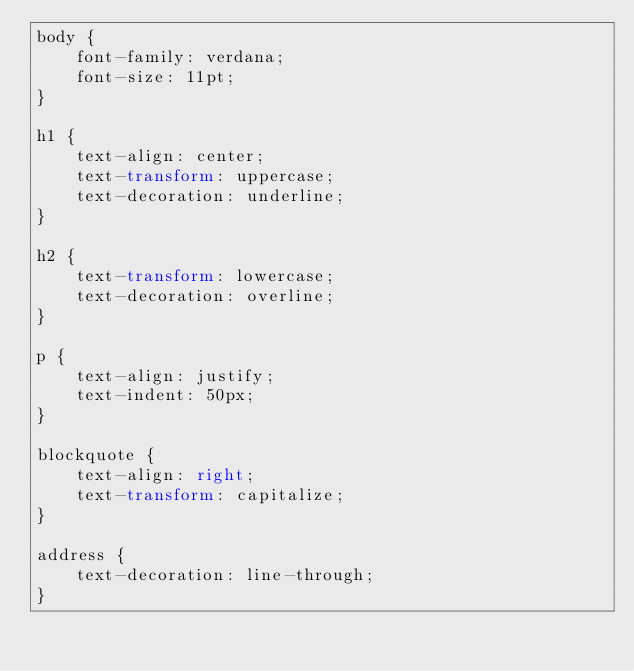<code> <loc_0><loc_0><loc_500><loc_500><_CSS_>body {
    font-family: verdana;
    font-size: 11pt;
}

h1 {
    text-align: center;
    text-transform: uppercase;
    text-decoration: underline;
}

h2 {
    text-transform: lowercase;
    text-decoration: overline;
}

p {
    text-align: justify;
    text-indent: 50px;
}

blockquote {
    text-align: right;
    text-transform: capitalize;
}

address {
    text-decoration: line-through;
}</code> 